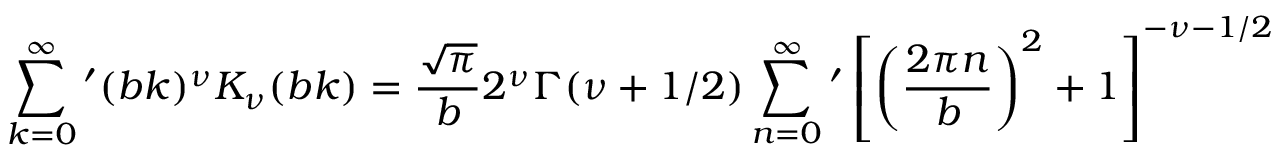<formula> <loc_0><loc_0><loc_500><loc_500>\sum _ { k = 0 } ^ { \infty } { ^ { \prime } } ( b k ) ^ { \nu } K _ { \nu } ( b k ) = \frac { \sqrt { \pi } } { b } 2 ^ { \nu } \Gamma ( \nu + 1 / 2 ) \sum _ { n = 0 } ^ { \infty } { ^ { \prime } } \left [ \left ( \frac { 2 \pi n } { b } \right ) ^ { 2 } + 1 \right ] ^ { - \nu - 1 / 2 }</formula> 